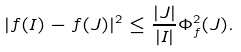<formula> <loc_0><loc_0><loc_500><loc_500>| f ( I ) - f ( J ) | ^ { 2 } \leq \frac { | J | } { | I | } \Phi ^ { 2 } _ { f } ( J ) .</formula> 